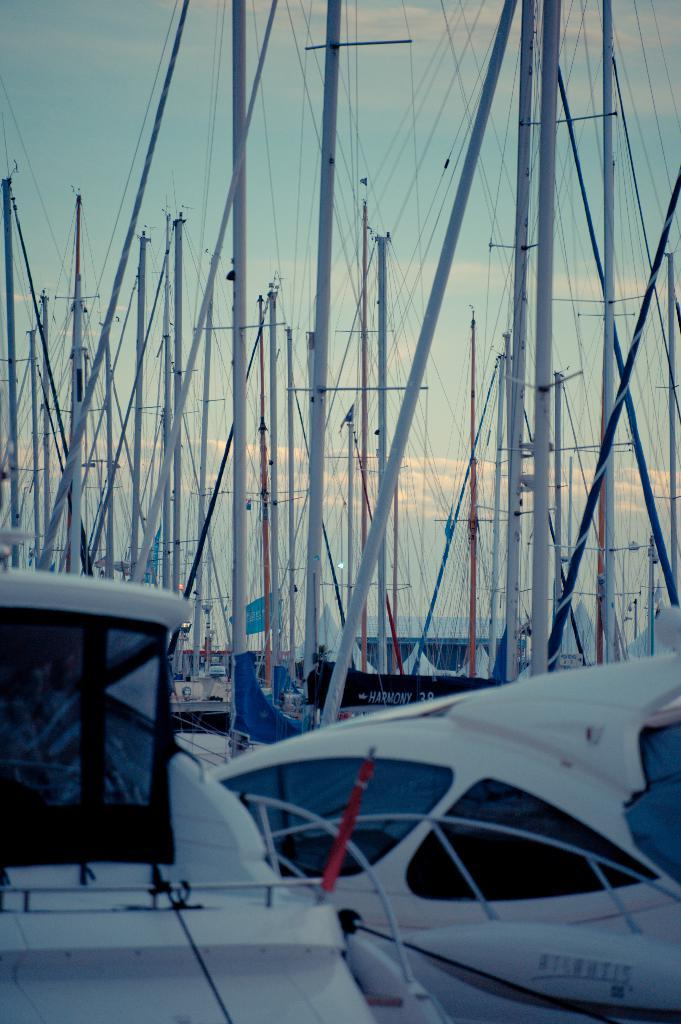What is located in the middle of the image? There are boats, poles, flags, and ropes in the middle of the image. What can be seen in the background of the image? There is sky and clouds visible in the background of the image. What type of objects are attached to the poles in the image? Flags are attached to the poles in the image. Where is the cushion placed on the stage in the image? There is no cushion or stage present in the image. How many feet are visible in the image? There are no feet visible in the image. 